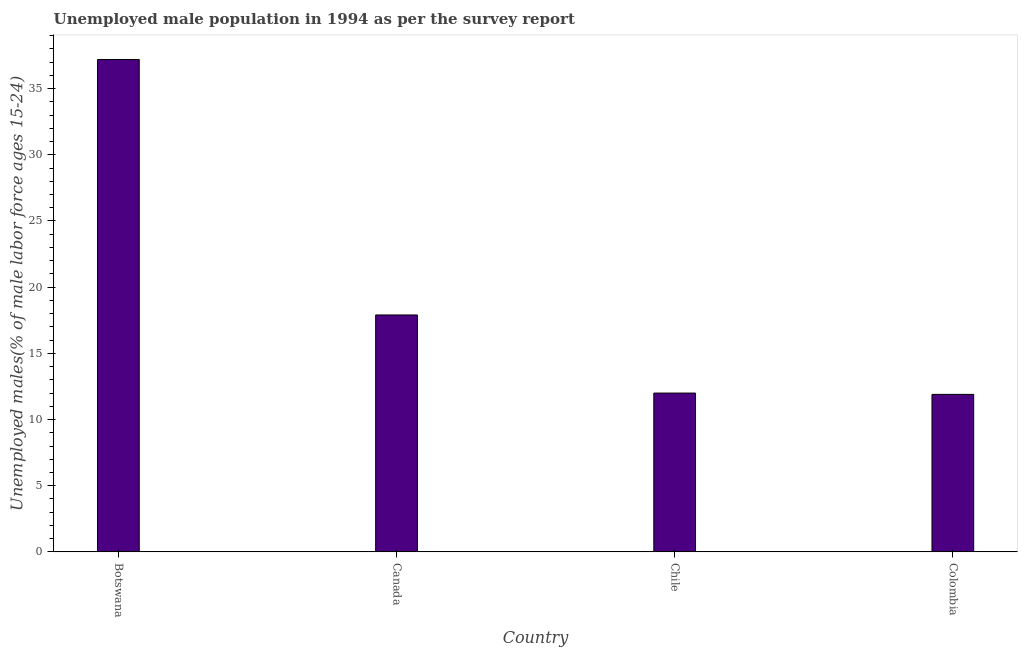Does the graph contain grids?
Provide a short and direct response. No. What is the title of the graph?
Ensure brevity in your answer.  Unemployed male population in 1994 as per the survey report. What is the label or title of the X-axis?
Ensure brevity in your answer.  Country. What is the label or title of the Y-axis?
Give a very brief answer. Unemployed males(% of male labor force ages 15-24). What is the unemployed male youth in Chile?
Make the answer very short. 12. Across all countries, what is the maximum unemployed male youth?
Keep it short and to the point. 37.2. Across all countries, what is the minimum unemployed male youth?
Give a very brief answer. 11.9. In which country was the unemployed male youth maximum?
Your answer should be compact. Botswana. In which country was the unemployed male youth minimum?
Your answer should be compact. Colombia. What is the sum of the unemployed male youth?
Offer a very short reply. 79. What is the difference between the unemployed male youth in Botswana and Colombia?
Ensure brevity in your answer.  25.3. What is the average unemployed male youth per country?
Make the answer very short. 19.75. What is the median unemployed male youth?
Keep it short and to the point. 14.95. What is the ratio of the unemployed male youth in Botswana to that in Canada?
Offer a terse response. 2.08. Is the unemployed male youth in Chile less than that in Colombia?
Your response must be concise. No. Is the difference between the unemployed male youth in Canada and Colombia greater than the difference between any two countries?
Keep it short and to the point. No. What is the difference between the highest and the second highest unemployed male youth?
Provide a succinct answer. 19.3. What is the difference between the highest and the lowest unemployed male youth?
Your answer should be very brief. 25.3. In how many countries, is the unemployed male youth greater than the average unemployed male youth taken over all countries?
Your answer should be compact. 1. How many bars are there?
Give a very brief answer. 4. Are all the bars in the graph horizontal?
Your answer should be very brief. No. What is the Unemployed males(% of male labor force ages 15-24) in Botswana?
Offer a terse response. 37.2. What is the Unemployed males(% of male labor force ages 15-24) of Canada?
Provide a short and direct response. 17.9. What is the Unemployed males(% of male labor force ages 15-24) of Colombia?
Provide a short and direct response. 11.9. What is the difference between the Unemployed males(% of male labor force ages 15-24) in Botswana and Canada?
Give a very brief answer. 19.3. What is the difference between the Unemployed males(% of male labor force ages 15-24) in Botswana and Chile?
Keep it short and to the point. 25.2. What is the difference between the Unemployed males(% of male labor force ages 15-24) in Botswana and Colombia?
Make the answer very short. 25.3. What is the difference between the Unemployed males(% of male labor force ages 15-24) in Canada and Chile?
Your answer should be compact. 5.9. What is the difference between the Unemployed males(% of male labor force ages 15-24) in Canada and Colombia?
Your answer should be compact. 6. What is the difference between the Unemployed males(% of male labor force ages 15-24) in Chile and Colombia?
Your answer should be compact. 0.1. What is the ratio of the Unemployed males(% of male labor force ages 15-24) in Botswana to that in Canada?
Keep it short and to the point. 2.08. What is the ratio of the Unemployed males(% of male labor force ages 15-24) in Botswana to that in Colombia?
Give a very brief answer. 3.13. What is the ratio of the Unemployed males(% of male labor force ages 15-24) in Canada to that in Chile?
Offer a terse response. 1.49. What is the ratio of the Unemployed males(% of male labor force ages 15-24) in Canada to that in Colombia?
Offer a terse response. 1.5. 